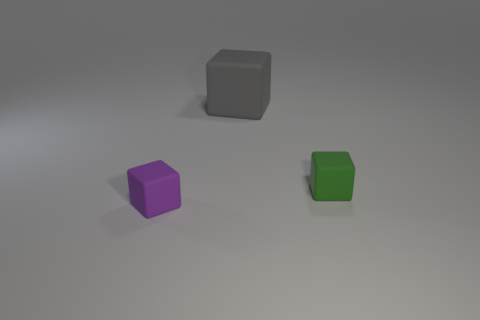Subtract 1 cubes. How many cubes are left? 2 Subtract all tiny blocks. How many blocks are left? 1 Add 3 large gray things. How many objects exist? 6 Subtract all brown metal blocks. Subtract all gray matte things. How many objects are left? 2 Add 3 green things. How many green things are left? 4 Add 3 red cylinders. How many red cylinders exist? 3 Subtract 0 blue cylinders. How many objects are left? 3 